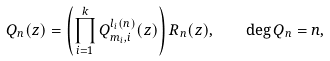Convert formula to latex. <formula><loc_0><loc_0><loc_500><loc_500>Q _ { n } ( z ) = \left ( \prod _ { i = 1 } ^ { k } Q _ { m _ { i } , i } ^ { l _ { i } ( n ) } ( z ) \right ) R _ { n } ( z ) , \quad \deg Q _ { n } = n ,</formula> 